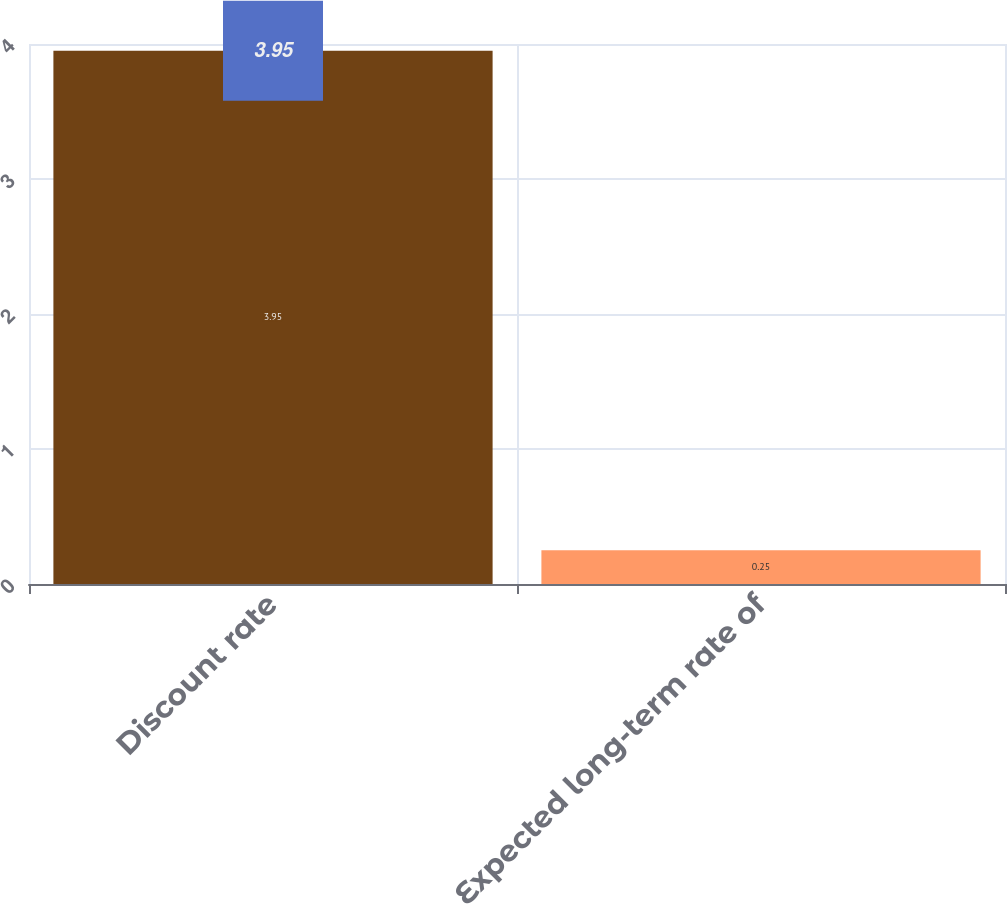Convert chart to OTSL. <chart><loc_0><loc_0><loc_500><loc_500><bar_chart><fcel>Discount rate<fcel>Expected long-term rate of<nl><fcel>3.95<fcel>0.25<nl></chart> 